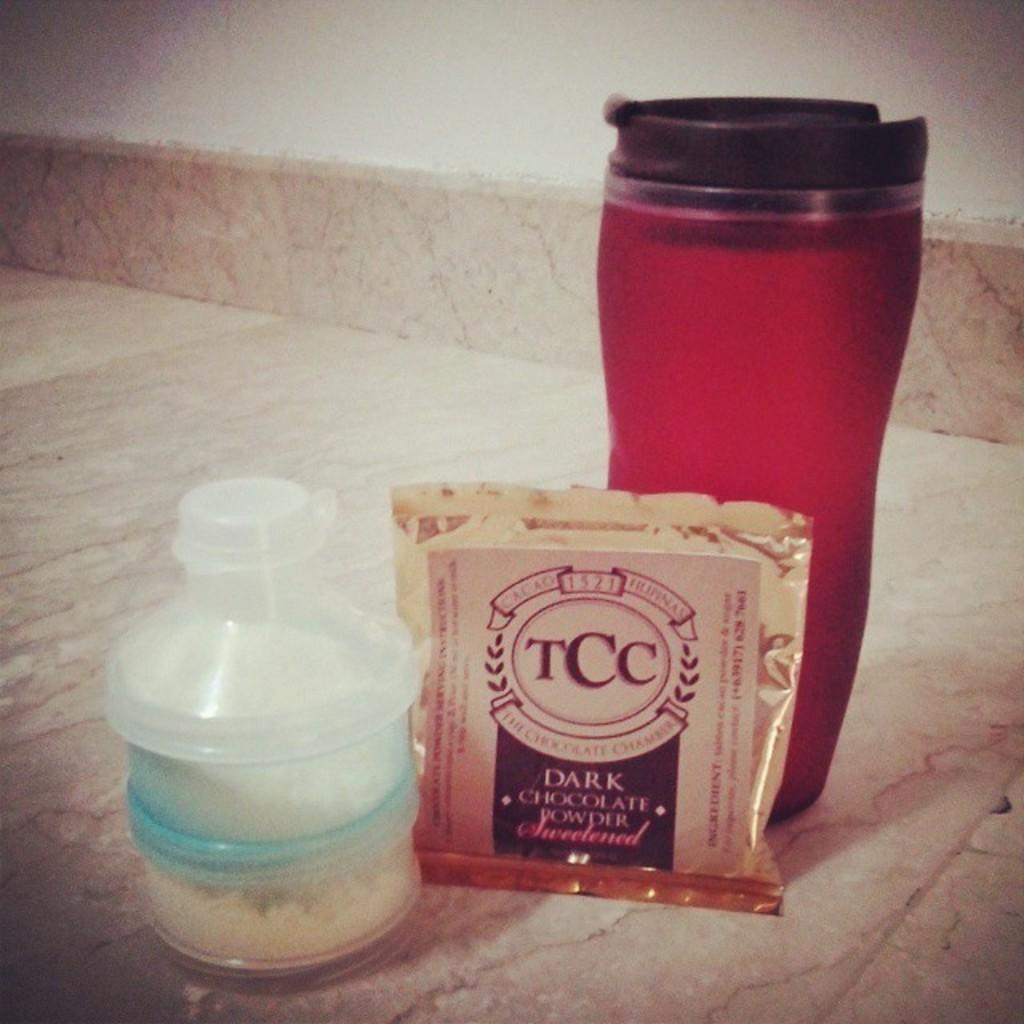<image>
Present a compact description of the photo's key features. A gold foil packet of TCC sweetene dark chocolate powder next to a red plastic mug and clear bottle with white powder. 